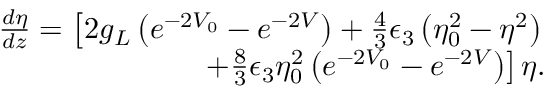Convert formula to latex. <formula><loc_0><loc_0><loc_500><loc_500>\begin{array} { r l r } & { \frac { d \eta } { d z } = \left [ 2 g _ { L } \left ( e ^ { - 2 V _ { 0 } } - e ^ { - 2 V } \right ) + \frac { 4 } { 3 } \epsilon _ { 3 } \left ( \eta _ { 0 } ^ { 2 } - \eta ^ { 2 } \right ) } \\ & { + \frac { 8 } { 3 } \epsilon _ { 3 } \eta _ { 0 } ^ { 2 } \left ( e ^ { - 2 V _ { 0 } } - e ^ { - 2 V } \right ) \right ] \eta . } \end{array}</formula> 